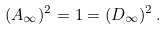Convert formula to latex. <formula><loc_0><loc_0><loc_500><loc_500>( A _ { \infty } ) ^ { 2 } = 1 = ( D _ { \infty } ) ^ { 2 } \, .</formula> 